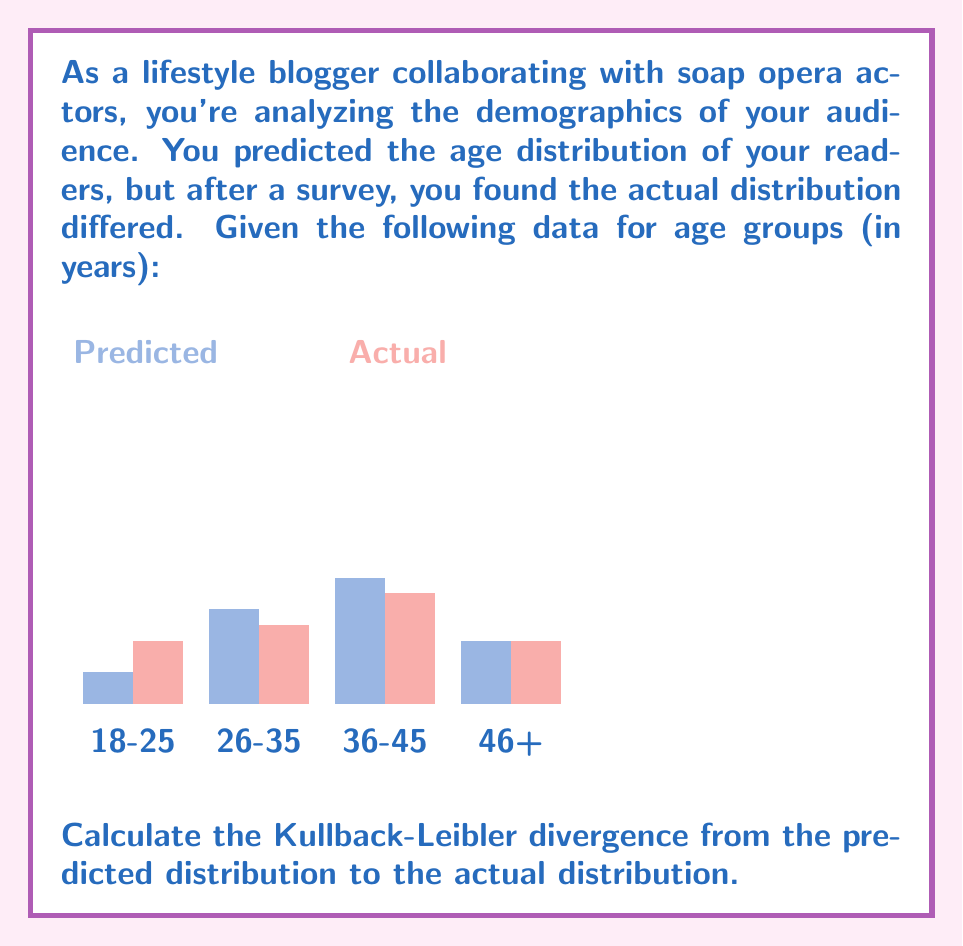What is the answer to this math problem? To calculate the Kullback-Leibler (KL) divergence from the predicted distribution P to the actual distribution Q, we use the formula:

$$ D_{KL}(P||Q) = \sum_{i} P(i) \log \frac{P(i)}{Q(i)} $$

Where P(i) is the predicted probability and Q(i) is the actual probability for each age group.

Let's calculate step by step:

1) For 18-25 age group:
   $P(1) = 0.1$, $Q(1) = 0.2$
   $0.1 \log \frac{0.1}{0.2} = 0.1 \log 0.5 = 0.1 \cdot (-0.301) = -0.0301$

2) For 26-35 age group:
   $P(2) = 0.3$, $Q(2) = 0.25$
   $0.3 \log \frac{0.3}{0.25} = 0.3 \log 1.2 = 0.3 \cdot 0.0792 = 0.02376$

3) For 36-45 age group:
   $P(3) = 0.4$, $Q(3) = 0.35$
   $0.4 \log \frac{0.4}{0.35} = 0.4 \log 1.1429 = 0.4 \cdot 0.0580 = 0.0232$

4) For 46+ age group:
   $P(4) = 0.2$, $Q(4) = 0.2$
   $0.2 \log \frac{0.2}{0.2} = 0.2 \log 1 = 0$

5) Sum all these values:
   $D_{KL}(P||Q) = -0.0301 + 0.02376 + 0.0232 + 0 = 0.01686$

Therefore, the Kullback-Leibler divergence from the predicted to the actual distribution is approximately 0.01686 nats.
Answer: 0.01686 nats 